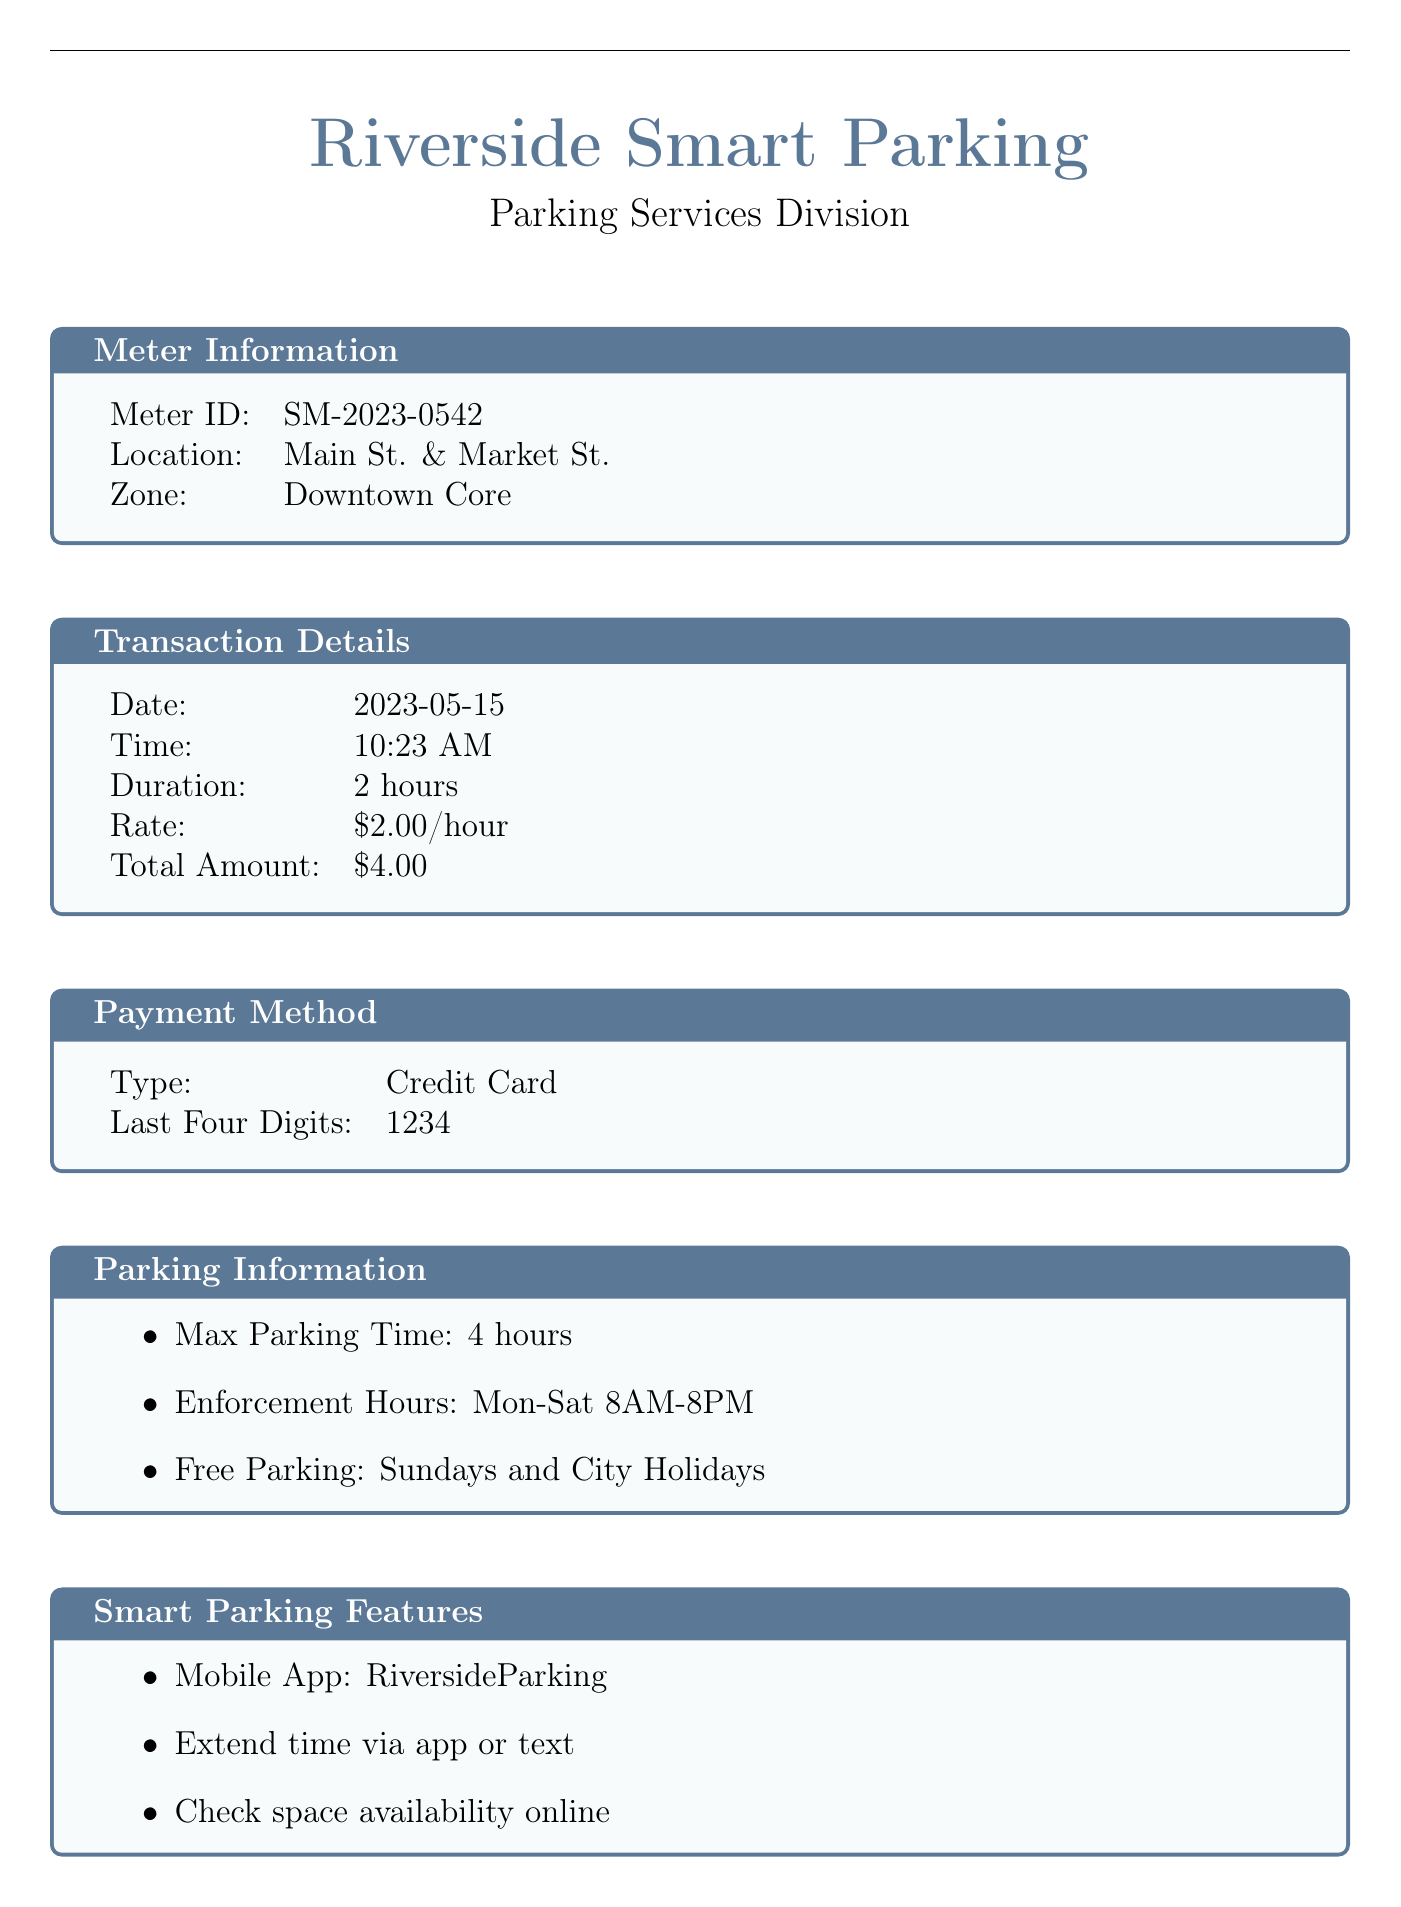What is the meter ID? The meter ID is provided in the meter information section of the receipt which identifies the specific smart meter used.
Answer: SM-2023-0542 What is the total amount paid? The total amount paid is calculated based on the duration of parking and the rate per hour, which is displayed in the transaction details.
Answer: $4.00 What method of payment was used? The receipt specifies the type of payment method used for the transaction, which is listed under payment method.
Answer: Credit Card What are the enforcement hours? The enforcement hours indicate when parking is monitored as noted in the parking information section of the receipt.
Answer: Mon-Sat 8AM-8PM What is the maximum parking time? The maximum parking time allowed is stated in the parking information section, indicating how long a vehicle can park in that spot.
Answer: 4 hours Which app is available for smart parking? The receipt includes information about a mobile app that users can use for smart parking, mentioned in the smart parking features.
Answer: RiversideParking What year was the original coin-operated meter installed? This information is found in the historical note section, which reflects on the history of parking meters in Riverside.
Answer: 1935 What is the transaction ID? The transaction ID is a unique identifier for the transaction mentioned at the bottom of the receipt.
Answer: TRN-20230515-104596 What message is included about environmental responsibility? The eco-friendly message highlights the benefits of using the smart meter in relation to the environment, stating the aim of reducing waste and emissions.
Answer: By using this smart meter, you're helping Riverside reduce paper waste and carbon emissions 